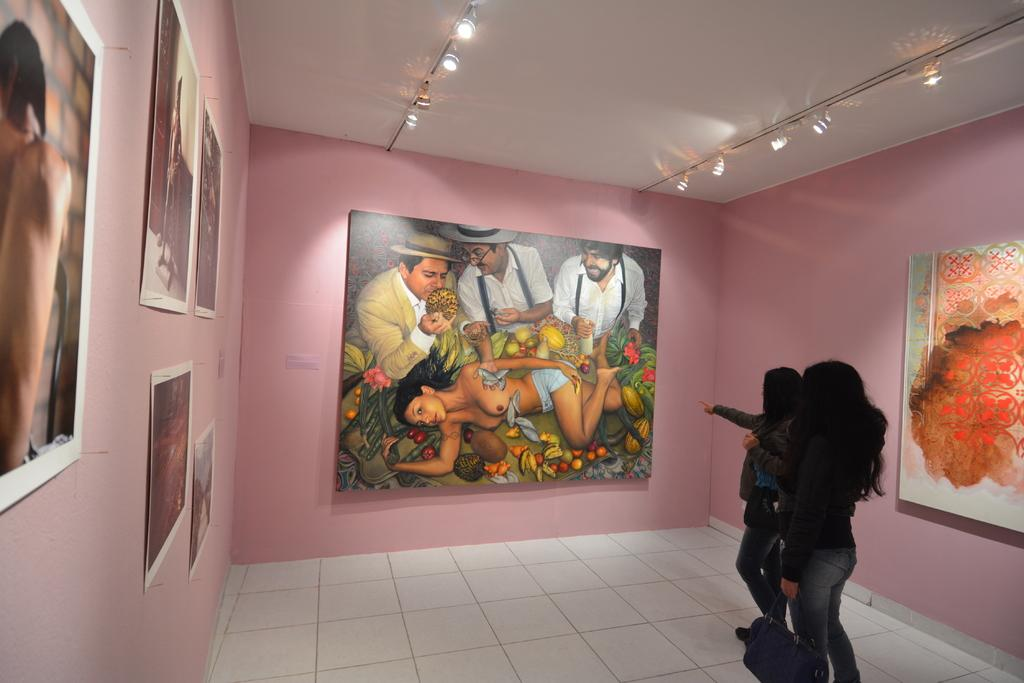How many people are in the image? There are two women in the image. What are the women doing in the image? The women are standing on the floor. What can be seen on the wall around the women? There are many posts attached to the wall around the women. How many brothers do the women have in the image? There is no information about the women's brothers in the image. What is the chance of winning a prize in the image? There is no indication of a prize or chance in the image. 